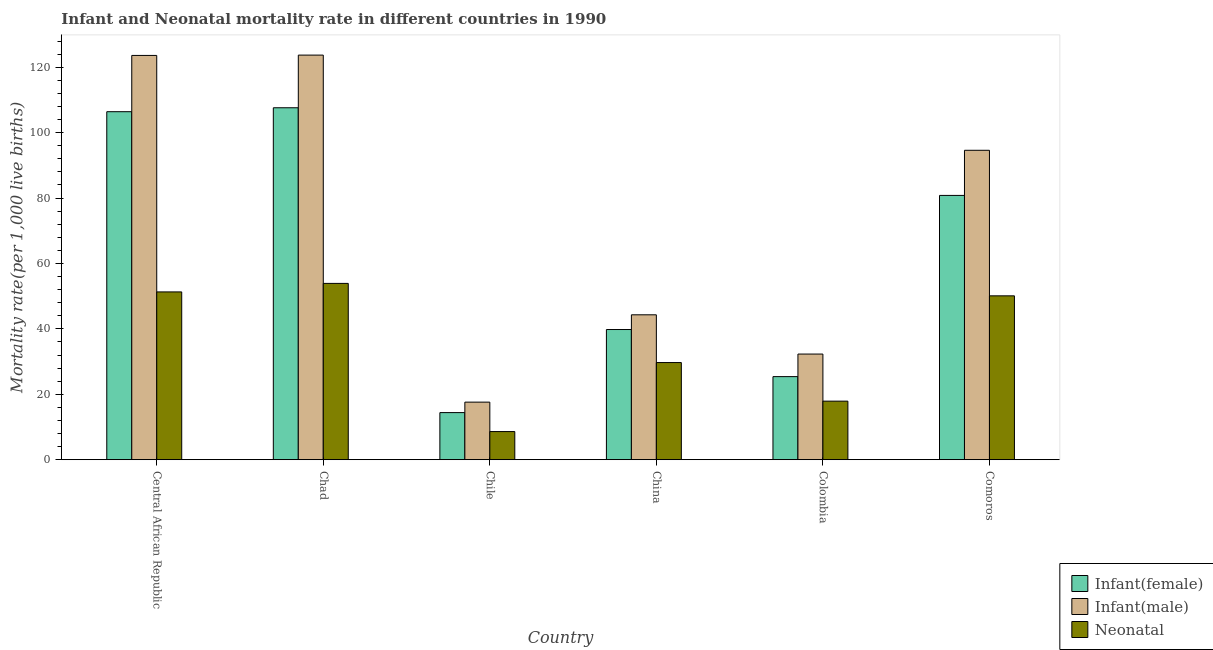How many different coloured bars are there?
Offer a terse response. 3. How many groups of bars are there?
Your answer should be compact. 6. Are the number of bars per tick equal to the number of legend labels?
Ensure brevity in your answer.  Yes. Are the number of bars on each tick of the X-axis equal?
Offer a terse response. Yes. What is the infant mortality rate(female) in Chad?
Offer a terse response. 107.6. Across all countries, what is the maximum infant mortality rate(female)?
Provide a short and direct response. 107.6. Across all countries, what is the minimum infant mortality rate(female)?
Offer a very short reply. 14.4. In which country was the neonatal mortality rate maximum?
Provide a short and direct response. Chad. In which country was the neonatal mortality rate minimum?
Provide a succinct answer. Chile. What is the total neonatal mortality rate in the graph?
Ensure brevity in your answer.  211.5. What is the difference between the infant mortality rate(male) in Chile and that in China?
Your answer should be compact. -26.7. What is the difference between the infant mortality rate(female) in Central African Republic and the infant mortality rate(male) in Colombia?
Make the answer very short. 74.1. What is the average neonatal mortality rate per country?
Provide a short and direct response. 35.25. What is the difference between the infant mortality rate(female) and infant mortality rate(male) in Central African Republic?
Make the answer very short. -17.2. In how many countries, is the infant mortality rate(female) greater than 104 ?
Your answer should be compact. 2. What is the ratio of the infant mortality rate(male) in Chad to that in Comoros?
Make the answer very short. 1.31. Is the difference between the infant mortality rate(male) in China and Comoros greater than the difference between the infant mortality rate(female) in China and Comoros?
Provide a short and direct response. No. What is the difference between the highest and the second highest neonatal mortality rate?
Your answer should be very brief. 2.6. What is the difference between the highest and the lowest neonatal mortality rate?
Make the answer very short. 45.3. In how many countries, is the neonatal mortality rate greater than the average neonatal mortality rate taken over all countries?
Your response must be concise. 3. Is the sum of the infant mortality rate(male) in Central African Republic and Comoros greater than the maximum neonatal mortality rate across all countries?
Your response must be concise. Yes. What does the 1st bar from the left in Comoros represents?
Keep it short and to the point. Infant(female). What does the 2nd bar from the right in Comoros represents?
Provide a short and direct response. Infant(male). How many bars are there?
Offer a terse response. 18. How many countries are there in the graph?
Your answer should be very brief. 6. What is the difference between two consecutive major ticks on the Y-axis?
Give a very brief answer. 20. Where does the legend appear in the graph?
Keep it short and to the point. Bottom right. How many legend labels are there?
Make the answer very short. 3. What is the title of the graph?
Your response must be concise. Infant and Neonatal mortality rate in different countries in 1990. Does "Taxes on goods and services" appear as one of the legend labels in the graph?
Ensure brevity in your answer.  No. What is the label or title of the Y-axis?
Your response must be concise. Mortality rate(per 1,0 live births). What is the Mortality rate(per 1,000 live births) of Infant(female) in Central African Republic?
Keep it short and to the point. 106.4. What is the Mortality rate(per 1,000 live births) of Infant(male) in Central African Republic?
Provide a succinct answer. 123.6. What is the Mortality rate(per 1,000 live births) of Neonatal  in Central African Republic?
Your response must be concise. 51.3. What is the Mortality rate(per 1,000 live births) in Infant(female) in Chad?
Provide a short and direct response. 107.6. What is the Mortality rate(per 1,000 live births) in Infant(male) in Chad?
Offer a very short reply. 123.7. What is the Mortality rate(per 1,000 live births) of Neonatal  in Chad?
Your answer should be compact. 53.9. What is the Mortality rate(per 1,000 live births) of Infant(female) in Chile?
Offer a terse response. 14.4. What is the Mortality rate(per 1,000 live births) in Neonatal  in Chile?
Give a very brief answer. 8.6. What is the Mortality rate(per 1,000 live births) of Infant(female) in China?
Keep it short and to the point. 39.8. What is the Mortality rate(per 1,000 live births) of Infant(male) in China?
Offer a very short reply. 44.3. What is the Mortality rate(per 1,000 live births) in Neonatal  in China?
Keep it short and to the point. 29.7. What is the Mortality rate(per 1,000 live births) of Infant(female) in Colombia?
Your response must be concise. 25.4. What is the Mortality rate(per 1,000 live births) of Infant(male) in Colombia?
Give a very brief answer. 32.3. What is the Mortality rate(per 1,000 live births) in Neonatal  in Colombia?
Make the answer very short. 17.9. What is the Mortality rate(per 1,000 live births) of Infant(female) in Comoros?
Ensure brevity in your answer.  80.8. What is the Mortality rate(per 1,000 live births) in Infant(male) in Comoros?
Offer a very short reply. 94.6. What is the Mortality rate(per 1,000 live births) in Neonatal  in Comoros?
Provide a short and direct response. 50.1. Across all countries, what is the maximum Mortality rate(per 1,000 live births) of Infant(female)?
Offer a very short reply. 107.6. Across all countries, what is the maximum Mortality rate(per 1,000 live births) in Infant(male)?
Offer a very short reply. 123.7. Across all countries, what is the maximum Mortality rate(per 1,000 live births) of Neonatal ?
Offer a terse response. 53.9. Across all countries, what is the minimum Mortality rate(per 1,000 live births) in Infant(female)?
Offer a terse response. 14.4. Across all countries, what is the minimum Mortality rate(per 1,000 live births) in Infant(male)?
Make the answer very short. 17.6. What is the total Mortality rate(per 1,000 live births) of Infant(female) in the graph?
Offer a terse response. 374.4. What is the total Mortality rate(per 1,000 live births) of Infant(male) in the graph?
Make the answer very short. 436.1. What is the total Mortality rate(per 1,000 live births) in Neonatal  in the graph?
Make the answer very short. 211.5. What is the difference between the Mortality rate(per 1,000 live births) in Infant(female) in Central African Republic and that in Chile?
Give a very brief answer. 92. What is the difference between the Mortality rate(per 1,000 live births) of Infant(male) in Central African Republic and that in Chile?
Keep it short and to the point. 106. What is the difference between the Mortality rate(per 1,000 live births) in Neonatal  in Central African Republic and that in Chile?
Provide a short and direct response. 42.7. What is the difference between the Mortality rate(per 1,000 live births) of Infant(female) in Central African Republic and that in China?
Provide a short and direct response. 66.6. What is the difference between the Mortality rate(per 1,000 live births) of Infant(male) in Central African Republic and that in China?
Your answer should be very brief. 79.3. What is the difference between the Mortality rate(per 1,000 live births) of Neonatal  in Central African Republic and that in China?
Offer a very short reply. 21.6. What is the difference between the Mortality rate(per 1,000 live births) in Infant(female) in Central African Republic and that in Colombia?
Give a very brief answer. 81. What is the difference between the Mortality rate(per 1,000 live births) of Infant(male) in Central African Republic and that in Colombia?
Your answer should be very brief. 91.3. What is the difference between the Mortality rate(per 1,000 live births) of Neonatal  in Central African Republic and that in Colombia?
Provide a short and direct response. 33.4. What is the difference between the Mortality rate(per 1,000 live births) in Infant(female) in Central African Republic and that in Comoros?
Make the answer very short. 25.6. What is the difference between the Mortality rate(per 1,000 live births) in Infant(female) in Chad and that in Chile?
Keep it short and to the point. 93.2. What is the difference between the Mortality rate(per 1,000 live births) of Infant(male) in Chad and that in Chile?
Provide a short and direct response. 106.1. What is the difference between the Mortality rate(per 1,000 live births) in Neonatal  in Chad and that in Chile?
Provide a short and direct response. 45.3. What is the difference between the Mortality rate(per 1,000 live births) in Infant(female) in Chad and that in China?
Your answer should be compact. 67.8. What is the difference between the Mortality rate(per 1,000 live births) in Infant(male) in Chad and that in China?
Your response must be concise. 79.4. What is the difference between the Mortality rate(per 1,000 live births) of Neonatal  in Chad and that in China?
Keep it short and to the point. 24.2. What is the difference between the Mortality rate(per 1,000 live births) of Infant(female) in Chad and that in Colombia?
Provide a short and direct response. 82.2. What is the difference between the Mortality rate(per 1,000 live births) in Infant(male) in Chad and that in Colombia?
Ensure brevity in your answer.  91.4. What is the difference between the Mortality rate(per 1,000 live births) of Neonatal  in Chad and that in Colombia?
Give a very brief answer. 36. What is the difference between the Mortality rate(per 1,000 live births) in Infant(female) in Chad and that in Comoros?
Your answer should be very brief. 26.8. What is the difference between the Mortality rate(per 1,000 live births) of Infant(male) in Chad and that in Comoros?
Your answer should be very brief. 29.1. What is the difference between the Mortality rate(per 1,000 live births) in Neonatal  in Chad and that in Comoros?
Offer a very short reply. 3.8. What is the difference between the Mortality rate(per 1,000 live births) of Infant(female) in Chile and that in China?
Give a very brief answer. -25.4. What is the difference between the Mortality rate(per 1,000 live births) of Infant(male) in Chile and that in China?
Your answer should be compact. -26.7. What is the difference between the Mortality rate(per 1,000 live births) of Neonatal  in Chile and that in China?
Give a very brief answer. -21.1. What is the difference between the Mortality rate(per 1,000 live births) in Infant(male) in Chile and that in Colombia?
Keep it short and to the point. -14.7. What is the difference between the Mortality rate(per 1,000 live births) of Neonatal  in Chile and that in Colombia?
Keep it short and to the point. -9.3. What is the difference between the Mortality rate(per 1,000 live births) of Infant(female) in Chile and that in Comoros?
Your answer should be very brief. -66.4. What is the difference between the Mortality rate(per 1,000 live births) in Infant(male) in Chile and that in Comoros?
Provide a succinct answer. -77. What is the difference between the Mortality rate(per 1,000 live births) of Neonatal  in Chile and that in Comoros?
Provide a succinct answer. -41.5. What is the difference between the Mortality rate(per 1,000 live births) of Neonatal  in China and that in Colombia?
Ensure brevity in your answer.  11.8. What is the difference between the Mortality rate(per 1,000 live births) in Infant(female) in China and that in Comoros?
Offer a terse response. -41. What is the difference between the Mortality rate(per 1,000 live births) in Infant(male) in China and that in Comoros?
Your answer should be compact. -50.3. What is the difference between the Mortality rate(per 1,000 live births) in Neonatal  in China and that in Comoros?
Your response must be concise. -20.4. What is the difference between the Mortality rate(per 1,000 live births) of Infant(female) in Colombia and that in Comoros?
Your answer should be compact. -55.4. What is the difference between the Mortality rate(per 1,000 live births) of Infant(male) in Colombia and that in Comoros?
Your answer should be compact. -62.3. What is the difference between the Mortality rate(per 1,000 live births) of Neonatal  in Colombia and that in Comoros?
Offer a very short reply. -32.2. What is the difference between the Mortality rate(per 1,000 live births) of Infant(female) in Central African Republic and the Mortality rate(per 1,000 live births) of Infant(male) in Chad?
Your answer should be compact. -17.3. What is the difference between the Mortality rate(per 1,000 live births) of Infant(female) in Central African Republic and the Mortality rate(per 1,000 live births) of Neonatal  in Chad?
Your answer should be compact. 52.5. What is the difference between the Mortality rate(per 1,000 live births) in Infant(male) in Central African Republic and the Mortality rate(per 1,000 live births) in Neonatal  in Chad?
Your response must be concise. 69.7. What is the difference between the Mortality rate(per 1,000 live births) of Infant(female) in Central African Republic and the Mortality rate(per 1,000 live births) of Infant(male) in Chile?
Offer a terse response. 88.8. What is the difference between the Mortality rate(per 1,000 live births) of Infant(female) in Central African Republic and the Mortality rate(per 1,000 live births) of Neonatal  in Chile?
Your response must be concise. 97.8. What is the difference between the Mortality rate(per 1,000 live births) in Infant(male) in Central African Republic and the Mortality rate(per 1,000 live births) in Neonatal  in Chile?
Your answer should be compact. 115. What is the difference between the Mortality rate(per 1,000 live births) in Infant(female) in Central African Republic and the Mortality rate(per 1,000 live births) in Infant(male) in China?
Offer a very short reply. 62.1. What is the difference between the Mortality rate(per 1,000 live births) of Infant(female) in Central African Republic and the Mortality rate(per 1,000 live births) of Neonatal  in China?
Offer a terse response. 76.7. What is the difference between the Mortality rate(per 1,000 live births) in Infant(male) in Central African Republic and the Mortality rate(per 1,000 live births) in Neonatal  in China?
Your answer should be very brief. 93.9. What is the difference between the Mortality rate(per 1,000 live births) of Infant(female) in Central African Republic and the Mortality rate(per 1,000 live births) of Infant(male) in Colombia?
Offer a very short reply. 74.1. What is the difference between the Mortality rate(per 1,000 live births) in Infant(female) in Central African Republic and the Mortality rate(per 1,000 live births) in Neonatal  in Colombia?
Give a very brief answer. 88.5. What is the difference between the Mortality rate(per 1,000 live births) of Infant(male) in Central African Republic and the Mortality rate(per 1,000 live births) of Neonatal  in Colombia?
Give a very brief answer. 105.7. What is the difference between the Mortality rate(per 1,000 live births) of Infant(female) in Central African Republic and the Mortality rate(per 1,000 live births) of Infant(male) in Comoros?
Provide a succinct answer. 11.8. What is the difference between the Mortality rate(per 1,000 live births) in Infant(female) in Central African Republic and the Mortality rate(per 1,000 live births) in Neonatal  in Comoros?
Your answer should be compact. 56.3. What is the difference between the Mortality rate(per 1,000 live births) in Infant(male) in Central African Republic and the Mortality rate(per 1,000 live births) in Neonatal  in Comoros?
Your answer should be compact. 73.5. What is the difference between the Mortality rate(per 1,000 live births) in Infant(male) in Chad and the Mortality rate(per 1,000 live births) in Neonatal  in Chile?
Offer a terse response. 115.1. What is the difference between the Mortality rate(per 1,000 live births) in Infant(female) in Chad and the Mortality rate(per 1,000 live births) in Infant(male) in China?
Your response must be concise. 63.3. What is the difference between the Mortality rate(per 1,000 live births) in Infant(female) in Chad and the Mortality rate(per 1,000 live births) in Neonatal  in China?
Your answer should be very brief. 77.9. What is the difference between the Mortality rate(per 1,000 live births) of Infant(male) in Chad and the Mortality rate(per 1,000 live births) of Neonatal  in China?
Your response must be concise. 94. What is the difference between the Mortality rate(per 1,000 live births) of Infant(female) in Chad and the Mortality rate(per 1,000 live births) of Infant(male) in Colombia?
Ensure brevity in your answer.  75.3. What is the difference between the Mortality rate(per 1,000 live births) of Infant(female) in Chad and the Mortality rate(per 1,000 live births) of Neonatal  in Colombia?
Make the answer very short. 89.7. What is the difference between the Mortality rate(per 1,000 live births) of Infant(male) in Chad and the Mortality rate(per 1,000 live births) of Neonatal  in Colombia?
Ensure brevity in your answer.  105.8. What is the difference between the Mortality rate(per 1,000 live births) in Infant(female) in Chad and the Mortality rate(per 1,000 live births) in Infant(male) in Comoros?
Offer a very short reply. 13. What is the difference between the Mortality rate(per 1,000 live births) of Infant(female) in Chad and the Mortality rate(per 1,000 live births) of Neonatal  in Comoros?
Provide a short and direct response. 57.5. What is the difference between the Mortality rate(per 1,000 live births) in Infant(male) in Chad and the Mortality rate(per 1,000 live births) in Neonatal  in Comoros?
Make the answer very short. 73.6. What is the difference between the Mortality rate(per 1,000 live births) in Infant(female) in Chile and the Mortality rate(per 1,000 live births) in Infant(male) in China?
Offer a very short reply. -29.9. What is the difference between the Mortality rate(per 1,000 live births) in Infant(female) in Chile and the Mortality rate(per 1,000 live births) in Neonatal  in China?
Keep it short and to the point. -15.3. What is the difference between the Mortality rate(per 1,000 live births) of Infant(male) in Chile and the Mortality rate(per 1,000 live births) of Neonatal  in China?
Keep it short and to the point. -12.1. What is the difference between the Mortality rate(per 1,000 live births) of Infant(female) in Chile and the Mortality rate(per 1,000 live births) of Infant(male) in Colombia?
Ensure brevity in your answer.  -17.9. What is the difference between the Mortality rate(per 1,000 live births) of Infant(female) in Chile and the Mortality rate(per 1,000 live births) of Neonatal  in Colombia?
Keep it short and to the point. -3.5. What is the difference between the Mortality rate(per 1,000 live births) of Infant(male) in Chile and the Mortality rate(per 1,000 live births) of Neonatal  in Colombia?
Provide a succinct answer. -0.3. What is the difference between the Mortality rate(per 1,000 live births) in Infant(female) in Chile and the Mortality rate(per 1,000 live births) in Infant(male) in Comoros?
Your answer should be compact. -80.2. What is the difference between the Mortality rate(per 1,000 live births) in Infant(female) in Chile and the Mortality rate(per 1,000 live births) in Neonatal  in Comoros?
Your answer should be compact. -35.7. What is the difference between the Mortality rate(per 1,000 live births) in Infant(male) in Chile and the Mortality rate(per 1,000 live births) in Neonatal  in Comoros?
Your answer should be compact. -32.5. What is the difference between the Mortality rate(per 1,000 live births) of Infant(female) in China and the Mortality rate(per 1,000 live births) of Neonatal  in Colombia?
Your answer should be very brief. 21.9. What is the difference between the Mortality rate(per 1,000 live births) in Infant(male) in China and the Mortality rate(per 1,000 live births) in Neonatal  in Colombia?
Offer a terse response. 26.4. What is the difference between the Mortality rate(per 1,000 live births) in Infant(female) in China and the Mortality rate(per 1,000 live births) in Infant(male) in Comoros?
Your answer should be compact. -54.8. What is the difference between the Mortality rate(per 1,000 live births) in Infant(female) in Colombia and the Mortality rate(per 1,000 live births) in Infant(male) in Comoros?
Provide a short and direct response. -69.2. What is the difference between the Mortality rate(per 1,000 live births) in Infant(female) in Colombia and the Mortality rate(per 1,000 live births) in Neonatal  in Comoros?
Your answer should be compact. -24.7. What is the difference between the Mortality rate(per 1,000 live births) of Infant(male) in Colombia and the Mortality rate(per 1,000 live births) of Neonatal  in Comoros?
Your response must be concise. -17.8. What is the average Mortality rate(per 1,000 live births) in Infant(female) per country?
Provide a succinct answer. 62.4. What is the average Mortality rate(per 1,000 live births) of Infant(male) per country?
Your answer should be compact. 72.68. What is the average Mortality rate(per 1,000 live births) of Neonatal  per country?
Offer a very short reply. 35.25. What is the difference between the Mortality rate(per 1,000 live births) in Infant(female) and Mortality rate(per 1,000 live births) in Infant(male) in Central African Republic?
Provide a short and direct response. -17.2. What is the difference between the Mortality rate(per 1,000 live births) of Infant(female) and Mortality rate(per 1,000 live births) of Neonatal  in Central African Republic?
Offer a terse response. 55.1. What is the difference between the Mortality rate(per 1,000 live births) in Infant(male) and Mortality rate(per 1,000 live births) in Neonatal  in Central African Republic?
Make the answer very short. 72.3. What is the difference between the Mortality rate(per 1,000 live births) of Infant(female) and Mortality rate(per 1,000 live births) of Infant(male) in Chad?
Offer a terse response. -16.1. What is the difference between the Mortality rate(per 1,000 live births) of Infant(female) and Mortality rate(per 1,000 live births) of Neonatal  in Chad?
Provide a short and direct response. 53.7. What is the difference between the Mortality rate(per 1,000 live births) of Infant(male) and Mortality rate(per 1,000 live births) of Neonatal  in Chad?
Ensure brevity in your answer.  69.8. What is the difference between the Mortality rate(per 1,000 live births) in Infant(female) and Mortality rate(per 1,000 live births) in Infant(male) in China?
Make the answer very short. -4.5. What is the difference between the Mortality rate(per 1,000 live births) in Infant(female) and Mortality rate(per 1,000 live births) in Neonatal  in China?
Make the answer very short. 10.1. What is the difference between the Mortality rate(per 1,000 live births) in Infant(female) and Mortality rate(per 1,000 live births) in Infant(male) in Colombia?
Provide a short and direct response. -6.9. What is the difference between the Mortality rate(per 1,000 live births) in Infant(female) and Mortality rate(per 1,000 live births) in Neonatal  in Colombia?
Offer a very short reply. 7.5. What is the difference between the Mortality rate(per 1,000 live births) of Infant(female) and Mortality rate(per 1,000 live births) of Neonatal  in Comoros?
Make the answer very short. 30.7. What is the difference between the Mortality rate(per 1,000 live births) of Infant(male) and Mortality rate(per 1,000 live births) of Neonatal  in Comoros?
Your answer should be compact. 44.5. What is the ratio of the Mortality rate(per 1,000 live births) in Infant(female) in Central African Republic to that in Chad?
Give a very brief answer. 0.99. What is the ratio of the Mortality rate(per 1,000 live births) in Infant(male) in Central African Republic to that in Chad?
Give a very brief answer. 1. What is the ratio of the Mortality rate(per 1,000 live births) of Neonatal  in Central African Republic to that in Chad?
Give a very brief answer. 0.95. What is the ratio of the Mortality rate(per 1,000 live births) in Infant(female) in Central African Republic to that in Chile?
Offer a very short reply. 7.39. What is the ratio of the Mortality rate(per 1,000 live births) of Infant(male) in Central African Republic to that in Chile?
Offer a very short reply. 7.02. What is the ratio of the Mortality rate(per 1,000 live births) of Neonatal  in Central African Republic to that in Chile?
Offer a terse response. 5.97. What is the ratio of the Mortality rate(per 1,000 live births) of Infant(female) in Central African Republic to that in China?
Give a very brief answer. 2.67. What is the ratio of the Mortality rate(per 1,000 live births) in Infant(male) in Central African Republic to that in China?
Make the answer very short. 2.79. What is the ratio of the Mortality rate(per 1,000 live births) of Neonatal  in Central African Republic to that in China?
Offer a terse response. 1.73. What is the ratio of the Mortality rate(per 1,000 live births) of Infant(female) in Central African Republic to that in Colombia?
Make the answer very short. 4.19. What is the ratio of the Mortality rate(per 1,000 live births) in Infant(male) in Central African Republic to that in Colombia?
Offer a very short reply. 3.83. What is the ratio of the Mortality rate(per 1,000 live births) of Neonatal  in Central African Republic to that in Colombia?
Offer a very short reply. 2.87. What is the ratio of the Mortality rate(per 1,000 live births) of Infant(female) in Central African Republic to that in Comoros?
Your answer should be compact. 1.32. What is the ratio of the Mortality rate(per 1,000 live births) of Infant(male) in Central African Republic to that in Comoros?
Your answer should be very brief. 1.31. What is the ratio of the Mortality rate(per 1,000 live births) of Infant(female) in Chad to that in Chile?
Your answer should be compact. 7.47. What is the ratio of the Mortality rate(per 1,000 live births) in Infant(male) in Chad to that in Chile?
Your response must be concise. 7.03. What is the ratio of the Mortality rate(per 1,000 live births) of Neonatal  in Chad to that in Chile?
Keep it short and to the point. 6.27. What is the ratio of the Mortality rate(per 1,000 live births) in Infant(female) in Chad to that in China?
Offer a very short reply. 2.7. What is the ratio of the Mortality rate(per 1,000 live births) in Infant(male) in Chad to that in China?
Offer a terse response. 2.79. What is the ratio of the Mortality rate(per 1,000 live births) of Neonatal  in Chad to that in China?
Make the answer very short. 1.81. What is the ratio of the Mortality rate(per 1,000 live births) of Infant(female) in Chad to that in Colombia?
Your answer should be compact. 4.24. What is the ratio of the Mortality rate(per 1,000 live births) in Infant(male) in Chad to that in Colombia?
Offer a terse response. 3.83. What is the ratio of the Mortality rate(per 1,000 live births) in Neonatal  in Chad to that in Colombia?
Keep it short and to the point. 3.01. What is the ratio of the Mortality rate(per 1,000 live births) of Infant(female) in Chad to that in Comoros?
Your response must be concise. 1.33. What is the ratio of the Mortality rate(per 1,000 live births) in Infant(male) in Chad to that in Comoros?
Provide a short and direct response. 1.31. What is the ratio of the Mortality rate(per 1,000 live births) in Neonatal  in Chad to that in Comoros?
Your answer should be very brief. 1.08. What is the ratio of the Mortality rate(per 1,000 live births) in Infant(female) in Chile to that in China?
Give a very brief answer. 0.36. What is the ratio of the Mortality rate(per 1,000 live births) in Infant(male) in Chile to that in China?
Provide a succinct answer. 0.4. What is the ratio of the Mortality rate(per 1,000 live births) in Neonatal  in Chile to that in China?
Offer a very short reply. 0.29. What is the ratio of the Mortality rate(per 1,000 live births) in Infant(female) in Chile to that in Colombia?
Offer a terse response. 0.57. What is the ratio of the Mortality rate(per 1,000 live births) in Infant(male) in Chile to that in Colombia?
Provide a succinct answer. 0.54. What is the ratio of the Mortality rate(per 1,000 live births) of Neonatal  in Chile to that in Colombia?
Provide a short and direct response. 0.48. What is the ratio of the Mortality rate(per 1,000 live births) of Infant(female) in Chile to that in Comoros?
Give a very brief answer. 0.18. What is the ratio of the Mortality rate(per 1,000 live births) of Infant(male) in Chile to that in Comoros?
Ensure brevity in your answer.  0.19. What is the ratio of the Mortality rate(per 1,000 live births) of Neonatal  in Chile to that in Comoros?
Keep it short and to the point. 0.17. What is the ratio of the Mortality rate(per 1,000 live births) in Infant(female) in China to that in Colombia?
Give a very brief answer. 1.57. What is the ratio of the Mortality rate(per 1,000 live births) in Infant(male) in China to that in Colombia?
Keep it short and to the point. 1.37. What is the ratio of the Mortality rate(per 1,000 live births) of Neonatal  in China to that in Colombia?
Your answer should be compact. 1.66. What is the ratio of the Mortality rate(per 1,000 live births) of Infant(female) in China to that in Comoros?
Your response must be concise. 0.49. What is the ratio of the Mortality rate(per 1,000 live births) in Infant(male) in China to that in Comoros?
Ensure brevity in your answer.  0.47. What is the ratio of the Mortality rate(per 1,000 live births) of Neonatal  in China to that in Comoros?
Provide a succinct answer. 0.59. What is the ratio of the Mortality rate(per 1,000 live births) of Infant(female) in Colombia to that in Comoros?
Offer a very short reply. 0.31. What is the ratio of the Mortality rate(per 1,000 live births) of Infant(male) in Colombia to that in Comoros?
Give a very brief answer. 0.34. What is the ratio of the Mortality rate(per 1,000 live births) in Neonatal  in Colombia to that in Comoros?
Keep it short and to the point. 0.36. What is the difference between the highest and the lowest Mortality rate(per 1,000 live births) of Infant(female)?
Offer a very short reply. 93.2. What is the difference between the highest and the lowest Mortality rate(per 1,000 live births) of Infant(male)?
Your response must be concise. 106.1. What is the difference between the highest and the lowest Mortality rate(per 1,000 live births) of Neonatal ?
Your answer should be compact. 45.3. 